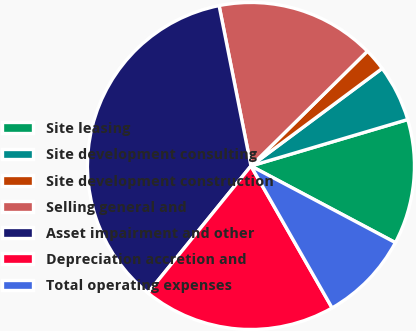<chart> <loc_0><loc_0><loc_500><loc_500><pie_chart><fcel>Site leasing<fcel>Site development consulting<fcel>Site development construction<fcel>Selling general and<fcel>Asset impairment and other<fcel>Depreciation accretion and<fcel>Total operating expenses<nl><fcel>12.35%<fcel>5.59%<fcel>2.21%<fcel>15.74%<fcel>36.03%<fcel>19.12%<fcel>8.97%<nl></chart> 